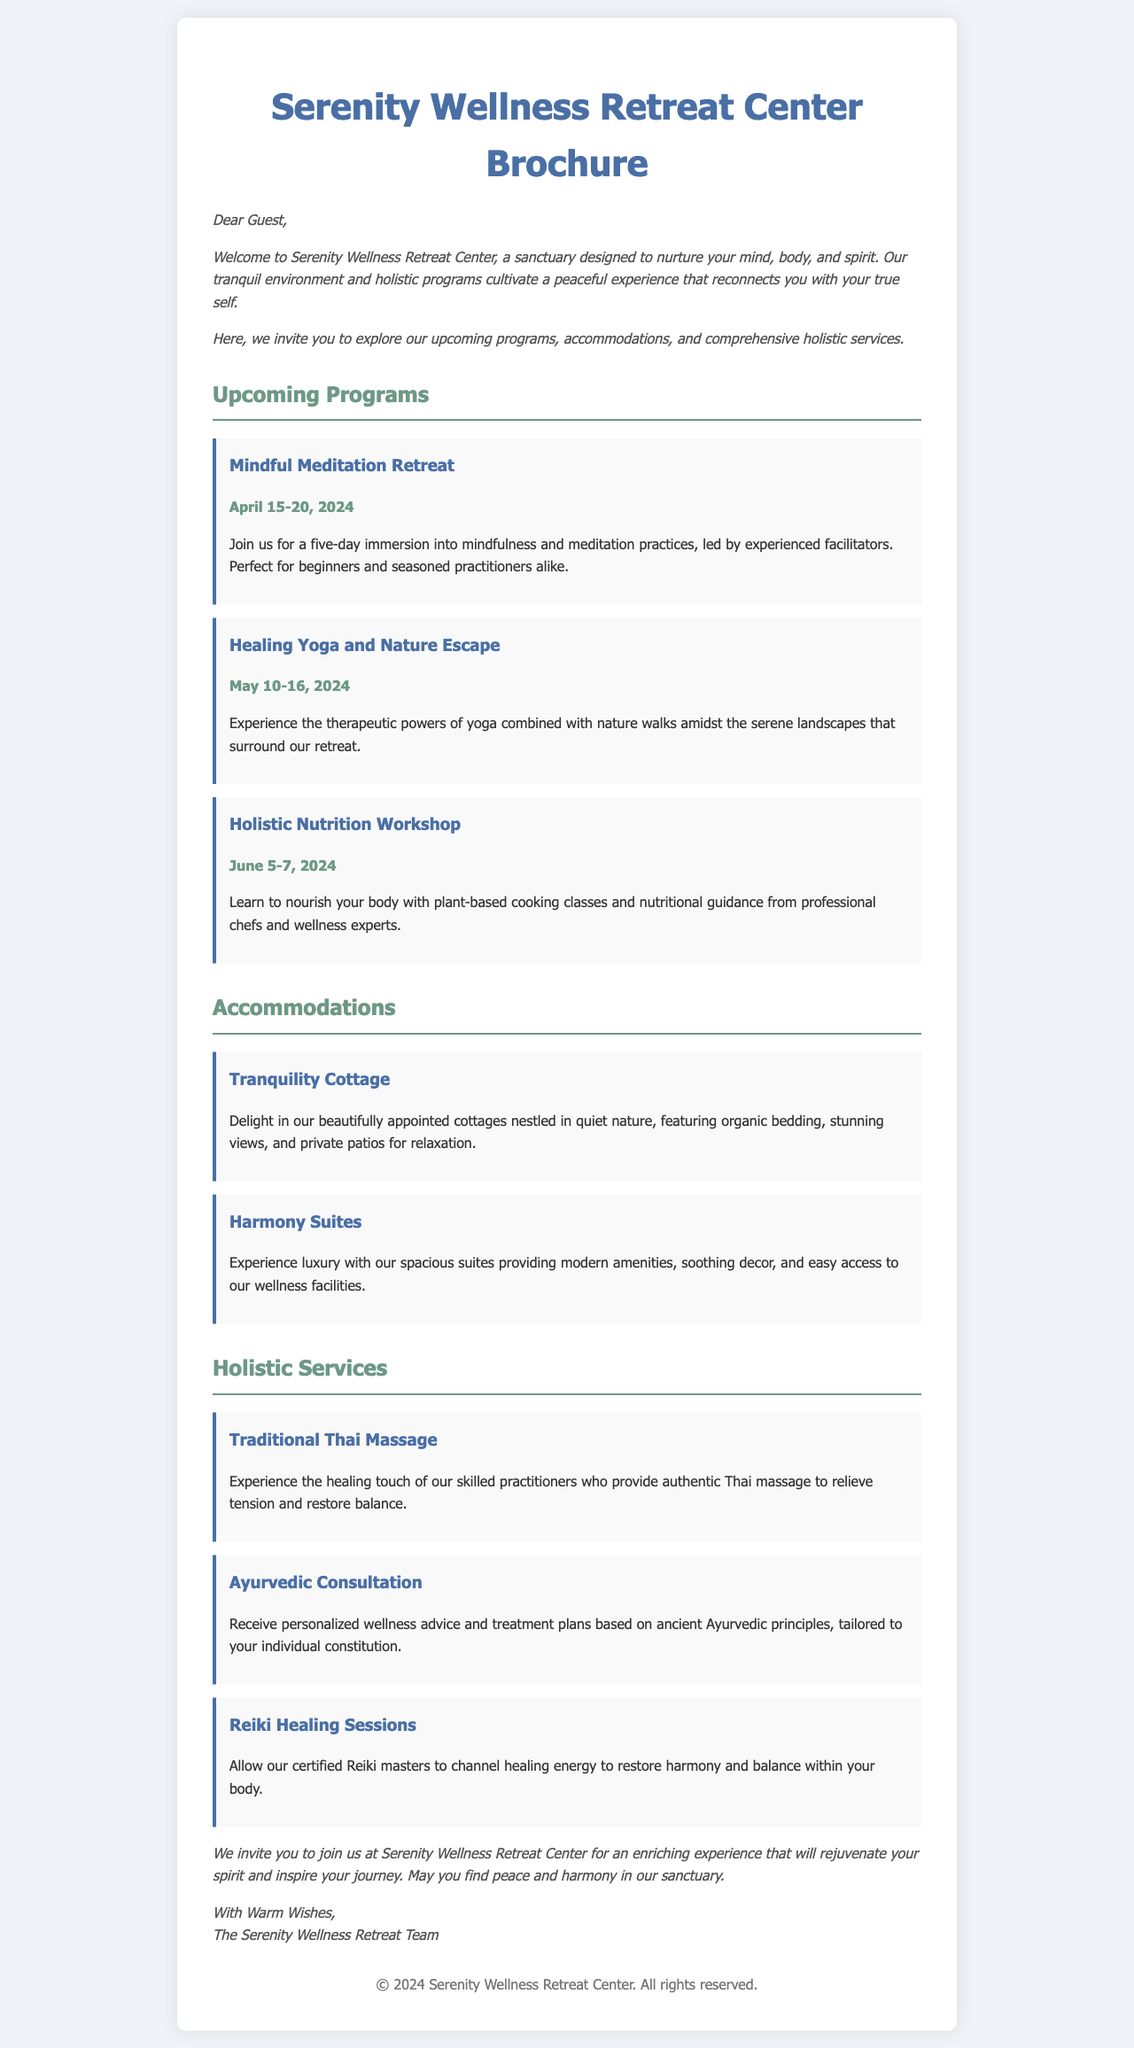what is the first program listed in the brochure? The first program mentioned in the document is the "Mindful Meditation Retreat," which is noted in the section about upcoming programs.
Answer: Mindful Meditation Retreat what are the dates for the Healing Yoga and Nature Escape program? The dates for this program are specifically mentioned in the document as May 10-16, 2024.
Answer: May 10-16, 2024 how many accommodations are mentioned in the brochure? The document states two accommodations: Tranquility Cottage and Harmony Suites.
Answer: 2 what type of massage service is offered? The document specifically mentions "Traditional Thai Massage" as one of the holistic services.
Answer: Traditional Thai Massage which accommodation provides luxury amenities? The "Harmony Suites" are described as providing luxury amenities in the accommodations section of the document.
Answer: Harmony Suites what is the duration of the Holistic Nutrition Workshop? The document states that this workshop takes place over two days from June 5-7, 2024.
Answer: 2 days what is emphasized in the closing remarks of the letter? The closing remarks highlight a desire for guests to find peace and harmony during their stay at the retreat.
Answer: Peace and harmony who leads the Mindful Meditation Retreat? The retreat is led by experienced facilitators as mentioned in the program description.
Answer: Experienced facilitators what style is used for the names of the holistic services? The names of the holistic services are presented in a bold and highlighted style within the document.
Answer: Bold and highlighted style 